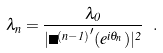Convert formula to latex. <formula><loc_0><loc_0><loc_500><loc_500>\lambda _ { n } = \frac { \lambda _ { 0 } } { | { \Phi ^ { ( n - 1 ) } } ^ { \prime } ( e ^ { i \theta _ { n } } ) | ^ { 2 } } \ .</formula> 